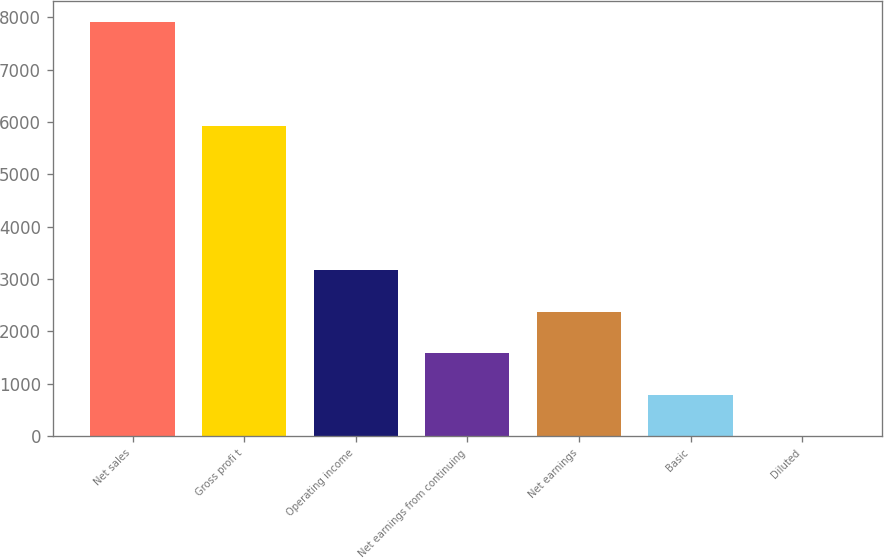<chart> <loc_0><loc_0><loc_500><loc_500><bar_chart><fcel>Net sales<fcel>Gross profi t<fcel>Operating income<fcel>Net earnings from continuing<fcel>Net earnings<fcel>Basic<fcel>Diluted<nl><fcel>7910.8<fcel>5914<fcel>3165.76<fcel>1584.08<fcel>2374.92<fcel>793.24<fcel>2.4<nl></chart> 